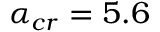<formula> <loc_0><loc_0><loc_500><loc_500>\alpha _ { c r } = 5 . 6</formula> 